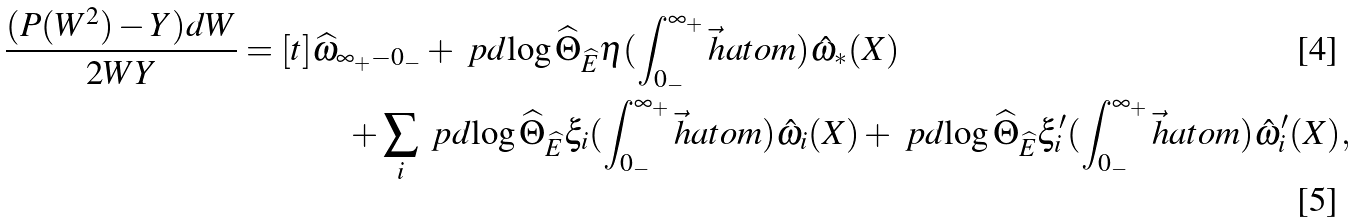Convert formula to latex. <formula><loc_0><loc_0><loc_500><loc_500>\frac { ( P ( W ^ { 2 } ) - Y ) d W } { 2 W Y } = [ t ] & \widehat { \omega } _ { \infty _ { + } - 0 _ { - } } + \ p d { \log \widehat { \Theta } _ { \widehat { E } } } { \eta } ( \int _ { 0 _ { - } } ^ { \infty _ { + } } \vec { h } a t o m ) \hat { \omega } _ { * } ( X ) \\ & \quad + \sum _ { i } \ p d { \log \widehat { \Theta } _ { \widehat { E } } } { \xi _ { i } } ( \int _ { 0 _ { - } } ^ { \infty _ { + } } \vec { h } a t o m ) \hat { \omega } _ { i } ( X ) + \ p d { \log \widehat { \Theta } _ { \widehat { E } } } { \xi ^ { \prime } _ { i } } ( \int _ { 0 _ { - } } ^ { \infty _ { + } } \vec { h } a t o m ) \hat { \omega } _ { i } ^ { \prime } ( X ) ,</formula> 